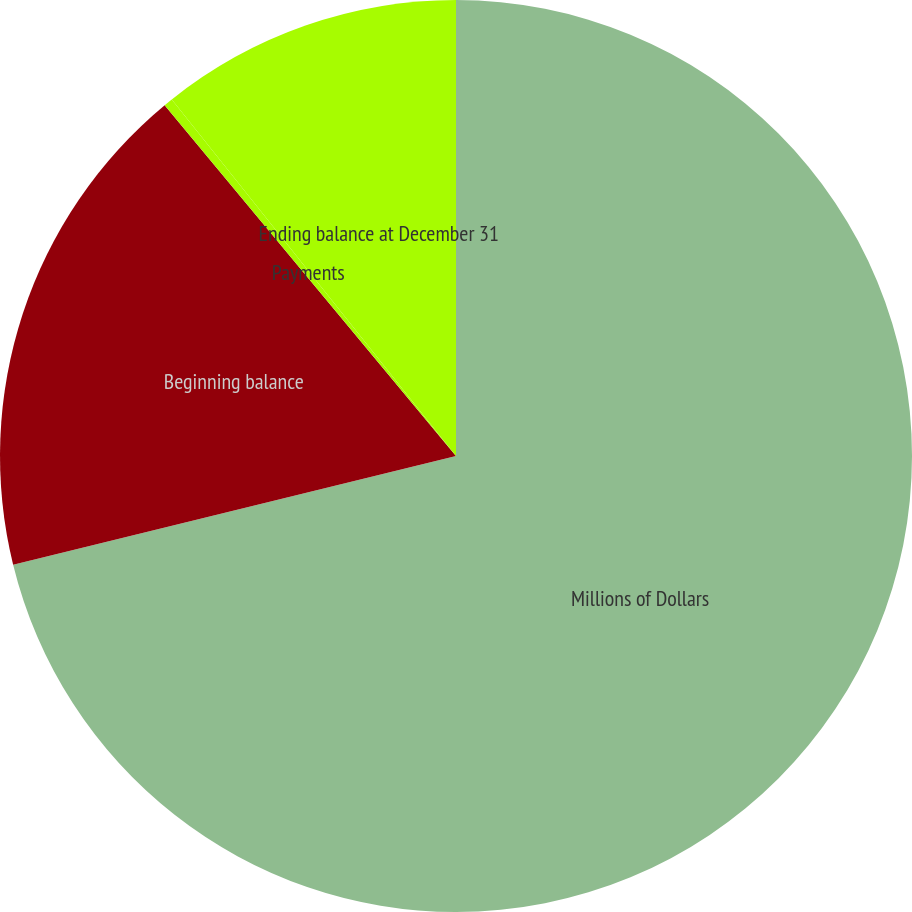<chart> <loc_0><loc_0><loc_500><loc_500><pie_chart><fcel>Millions of Dollars<fcel>Beginning balance<fcel>Payments<fcel>Ending balance at December 31<nl><fcel>71.17%<fcel>17.8%<fcel>0.32%<fcel>10.71%<nl></chart> 